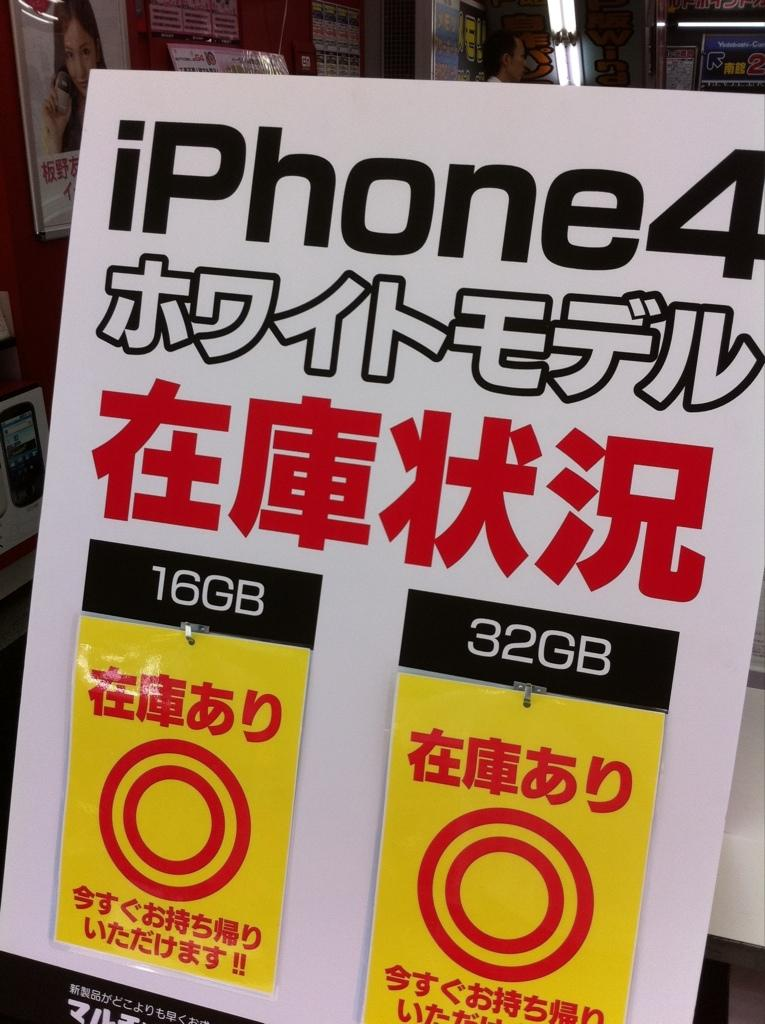<image>
Render a clear and concise summary of the photo. A large iPhone4 sign has labels 16GB and 32GB on it. 